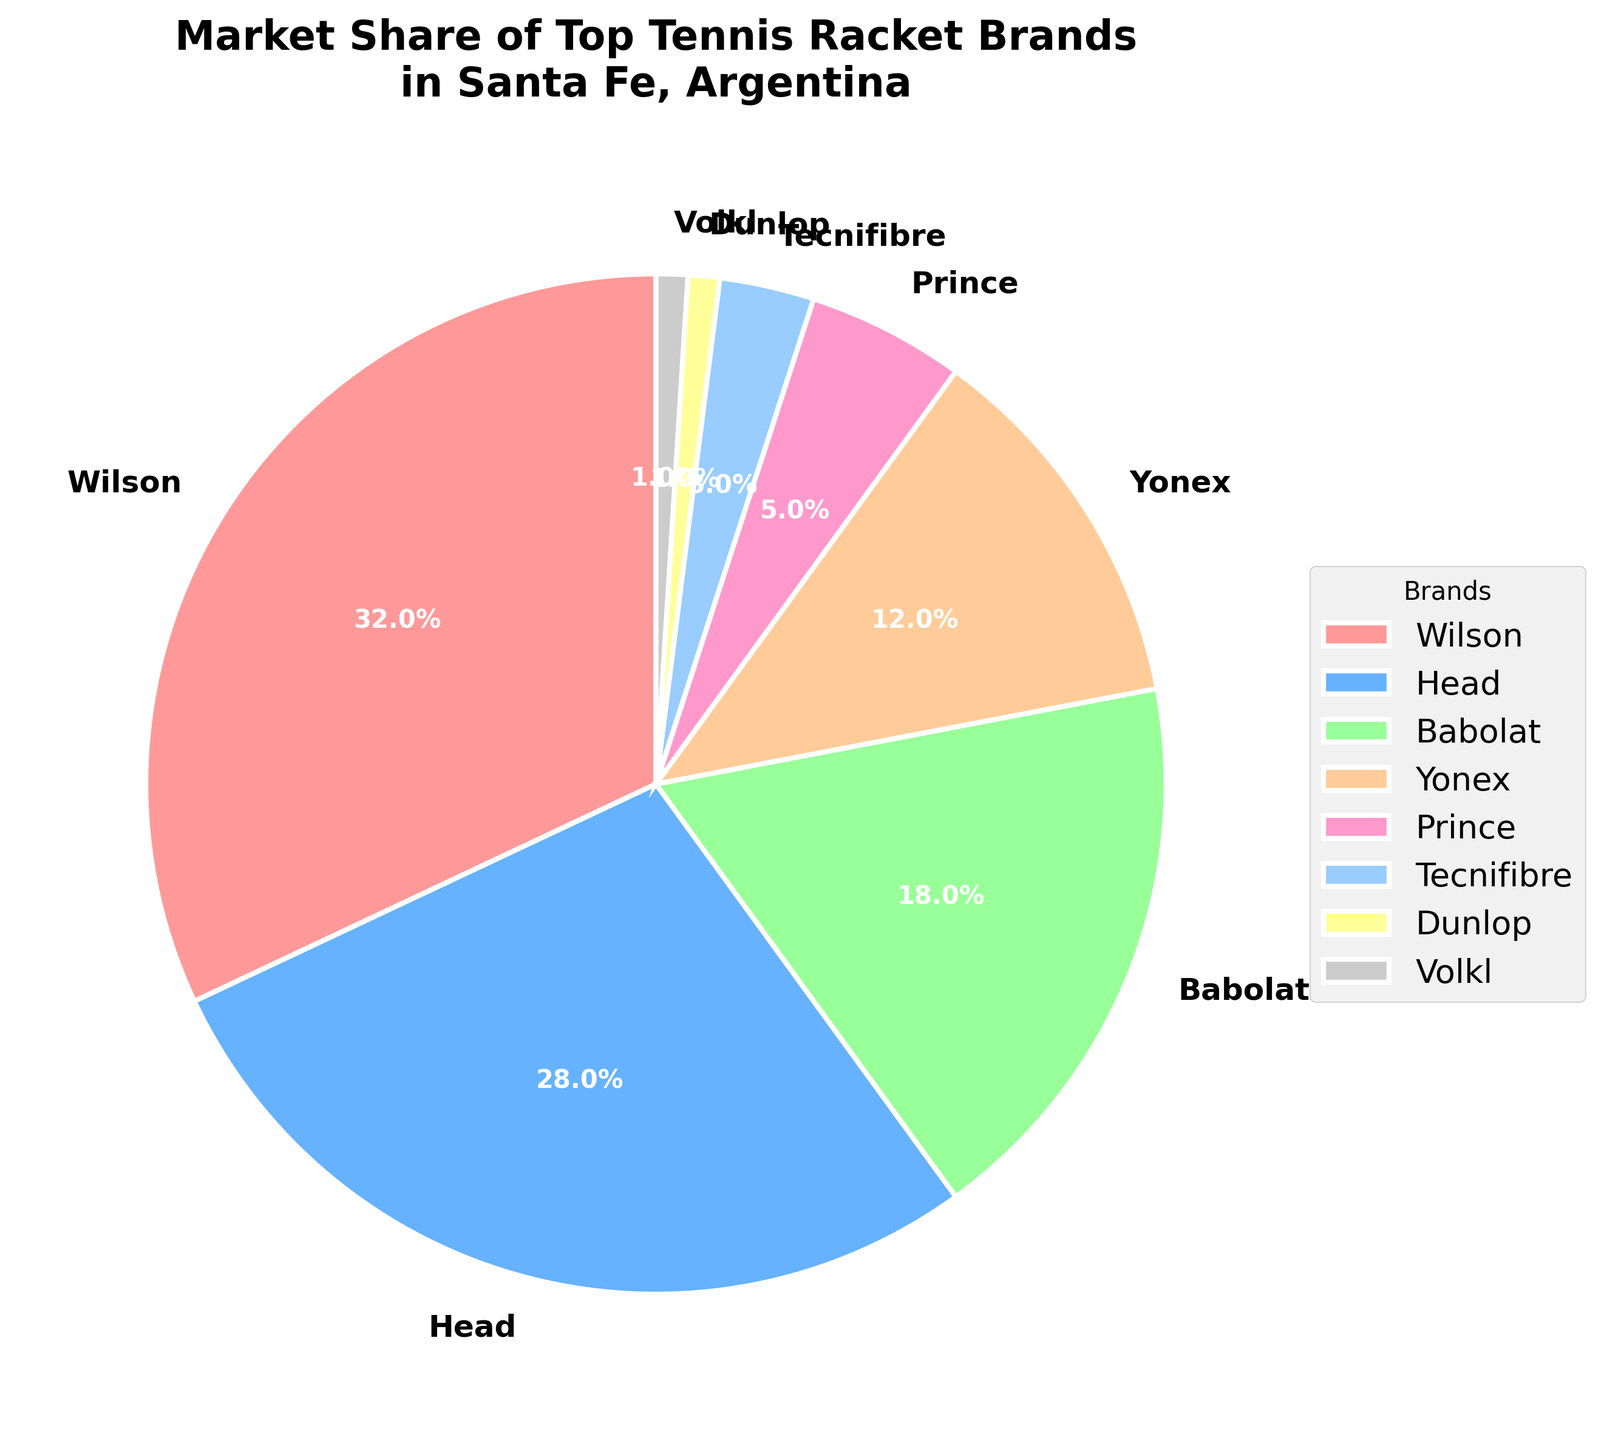What percentage of the market share is held by Wilson and Head combined? Summing the market share percentages of Wilson (32%) and Head (28%) gives: 32% + 28% = 60%
Answer: 60% Which brand has the lowest market share? Identifying the brand with the lowest percentage on the pie chart, we see Dunlop and Volkl both have 1%.
Answer: Dunlop and Volkl Is the market share of Babolat greater than double that of Yonex? Comparing Babolat's market share (18%) to twice Yonex's (12% * 2 = 24%), we see 18% < 24%.
Answer: No How many brands have a market share of 5% or lower? Identifying brands with 5% or lower share, we see Prince (5%), Tecnifibre (3%), Dunlop (1%), and Volkl (1%), totaling 4 brands.
Answer: 4 Which brand occupies the second-largest market share and what is it? Identifying the second-largest market share, we see Head (28%).
Answer: Head, 28% What is the total market share of brands with less than 10% share each? Summing up the market shares of Yonex (12%), Prince (5%), Tecnifibre (3%), Dunlop (1%), and Volkl (1%) gives: 12% + 5% + 3% + 1% + 1% = 22%.
Answer: 22% Which brand is represented by the yellow color in the pie chart? Observing the yellow segment in the chart, it represents Yonex, holding 12% market share.
Answer: Yonex Are there any brands that hold an equal market share? If so, which ones and what is it? Looking for equal shares, we see Dunlop and Volkl each hold 1% of the market.
Answer: Dunlop and Volkl, 1% Comparing Wilson and Babolat, how much higher is Wilson's market share? Subtracting Babolat's share from Wilson's: 32% - 18% = 14%.
Answer: 14% Is the combined market share of Tecnifibre and Yonex greater than that of Head? Summing Tecnifibre (3%) and Yonex (12%), and comparing to Head (28%): 3% + 12% = 15%, which is less than 28%.
Answer: No 